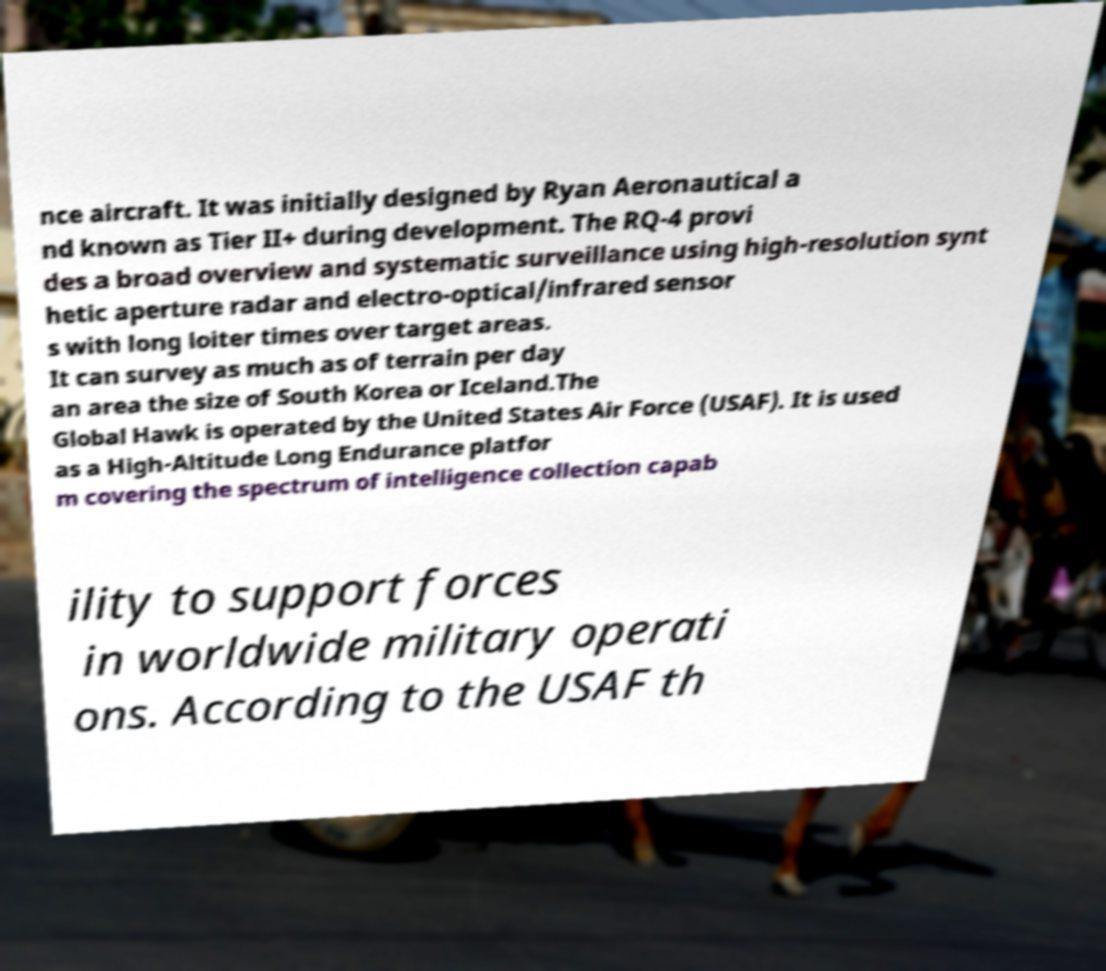What messages or text are displayed in this image? I need them in a readable, typed format. nce aircraft. It was initially designed by Ryan Aeronautical a nd known as Tier II+ during development. The RQ-4 provi des a broad overview and systematic surveillance using high-resolution synt hetic aperture radar and electro-optical/infrared sensor s with long loiter times over target areas. It can survey as much as of terrain per day an area the size of South Korea or Iceland.The Global Hawk is operated by the United States Air Force (USAF). It is used as a High-Altitude Long Endurance platfor m covering the spectrum of intelligence collection capab ility to support forces in worldwide military operati ons. According to the USAF th 